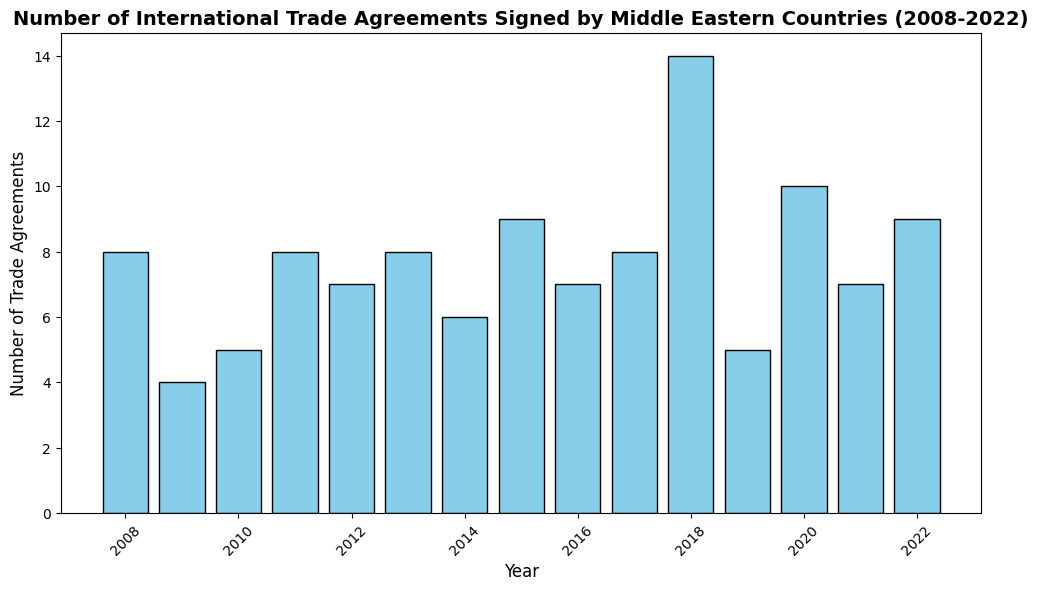What was the total number of trade agreements signed in the year with the highest number of agreements? To find the answer, look at the histogram and identify the year with the tallest bar. The tallest bar represents the year 2018. The label at the top of the bar indicates the number of trade agreements, which is 14.
Answer: 14 What is the average number of trade agreements signed per year from 2008 to 2022? To find the average, sum the total number of trade agreements over all years and then divide by the number of years (15). Sum of agreements = 8 + 4 + 5 + 8 + 7 + 9 + 8 + 13 + 5 + 10 + 8 + 11 + 9 + 8 + 9 = 122. Therefore, the average is 122 / 15 ≈ 8.13.
Answer: 8.13 In which year did Middle Eastern countries sign the fewest trade agreements, and how many were signed that year? By observing the histogram, identify the year with the shortest bar, which occurs in 2010. The height of the bar indicates that the total number of trade agreements signed in 2010 was 5.
Answer: 2010, 5 How does the number of trade agreements signed in 2013 compare to those signed in 2020? Look at the bars for the years 2013 and 2020. The height of the bar for 2013 is 8, and for 2020 it is 10. Since 10 is greater than 8, more trade agreements were signed in 2020.
Answer: More in 2020 Which year had the second highest number of trade agreements, and what was the number? Find the second tallest bar after identifying the highest. The tallest is 2018 with 14 agreements. The second tallest bar represents the year 2015 with 11 agreements.
Answer: 2015, 11 How much did the number of trade agreements change from 2011 to 2012? Compare the heights of the bars for 2011 and 2012. The height of the bar for 2011 indicates 8 agreements, and for 2012 it is 7 agreements. The change is calculated as 8 - 7 = 1.
Answer: Decreased by 1 During how many years were exactly 9 trade agreements signed? Count the bars that reach the height representing 9 trade agreements. By observing, only the years 2014 and 2022 have exactly 9 agreements.
Answer: 2 years What years had a consistent decline in the number of trade agreements for three consecutive years? Identify any set of three bars where each year has fewer agreements than the previous year. From 2008 (8 agreements) to 2010 (5 agreements), there is a decline.
Answer: 2008-2010 